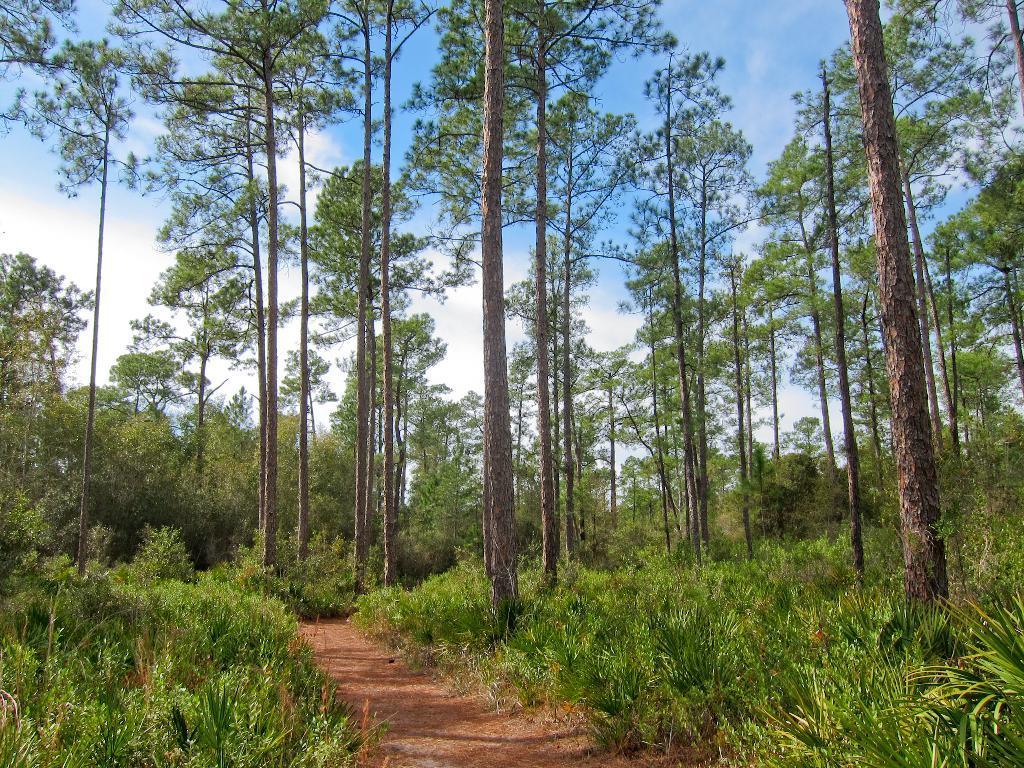Describe this image in one or two sentences. In this image, there are so many trees, plants and a walkway. In the background, there is the sky. 